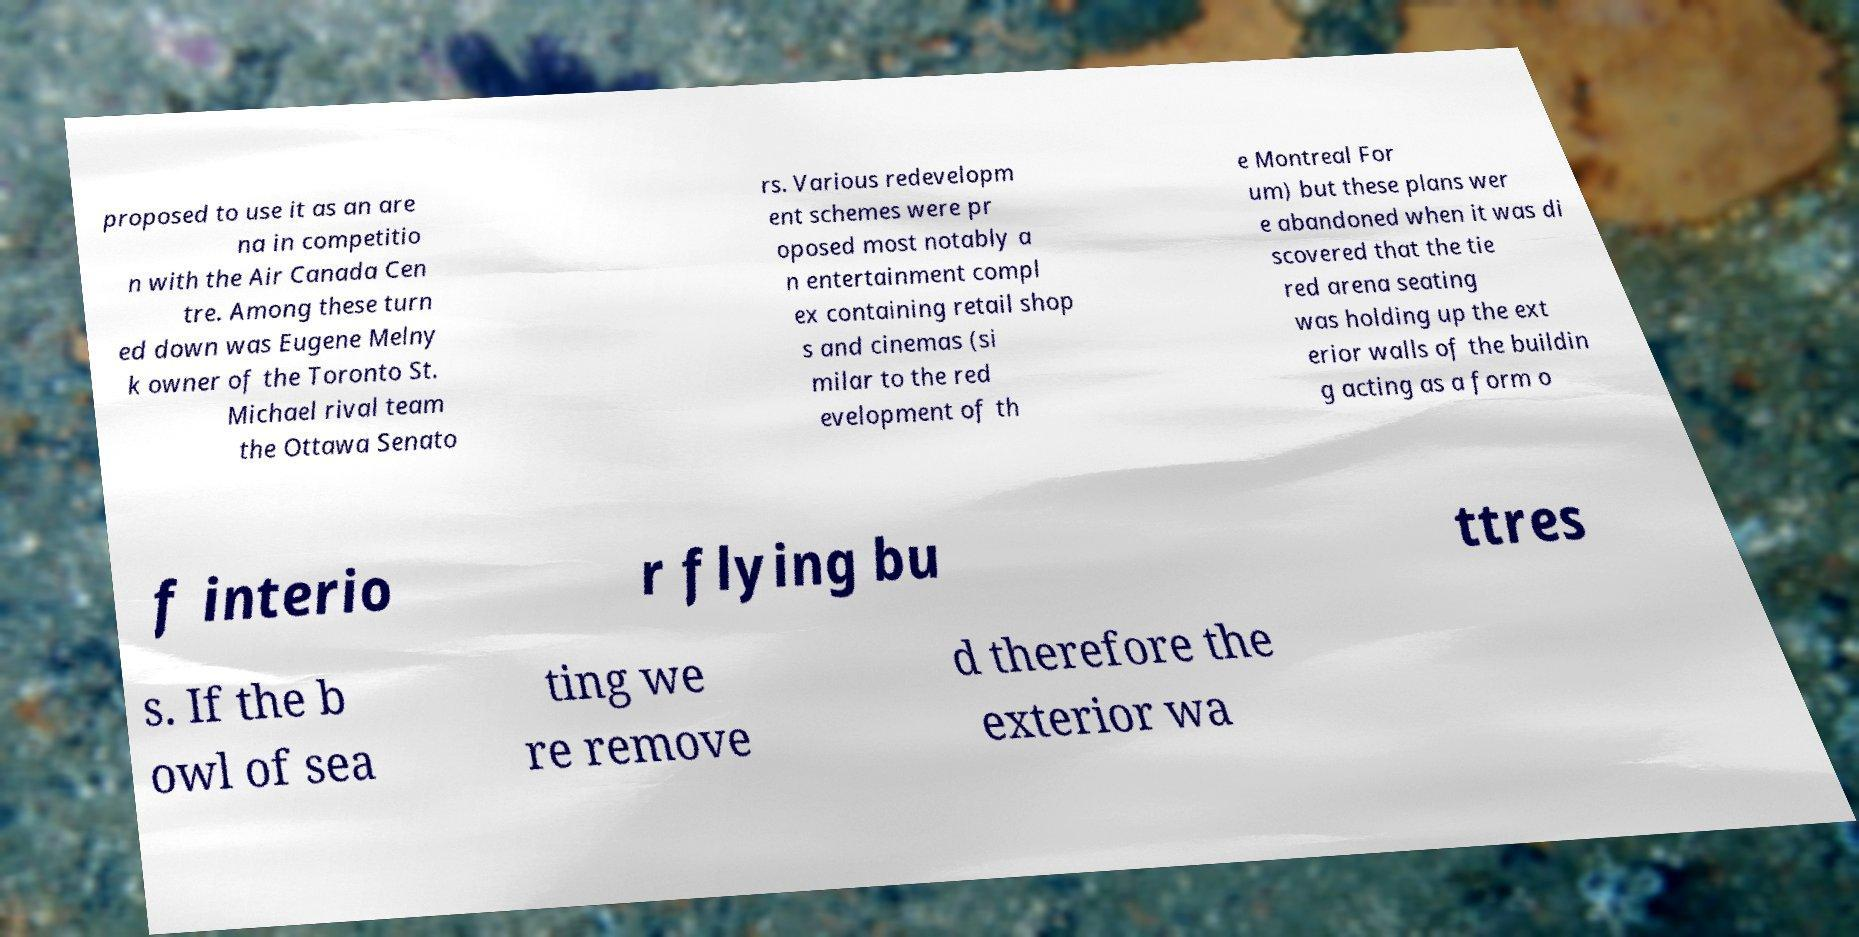Can you accurately transcribe the text from the provided image for me? proposed to use it as an are na in competitio n with the Air Canada Cen tre. Among these turn ed down was Eugene Melny k owner of the Toronto St. Michael rival team the Ottawa Senato rs. Various redevelopm ent schemes were pr oposed most notably a n entertainment compl ex containing retail shop s and cinemas (si milar to the red evelopment of th e Montreal For um) but these plans wer e abandoned when it was di scovered that the tie red arena seating was holding up the ext erior walls of the buildin g acting as a form o f interio r flying bu ttres s. If the b owl of sea ting we re remove d therefore the exterior wa 